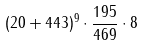<formula> <loc_0><loc_0><loc_500><loc_500>( 2 0 + 4 4 3 ) ^ { 9 } \cdot \frac { 1 9 5 } { 4 6 9 } \cdot 8</formula> 